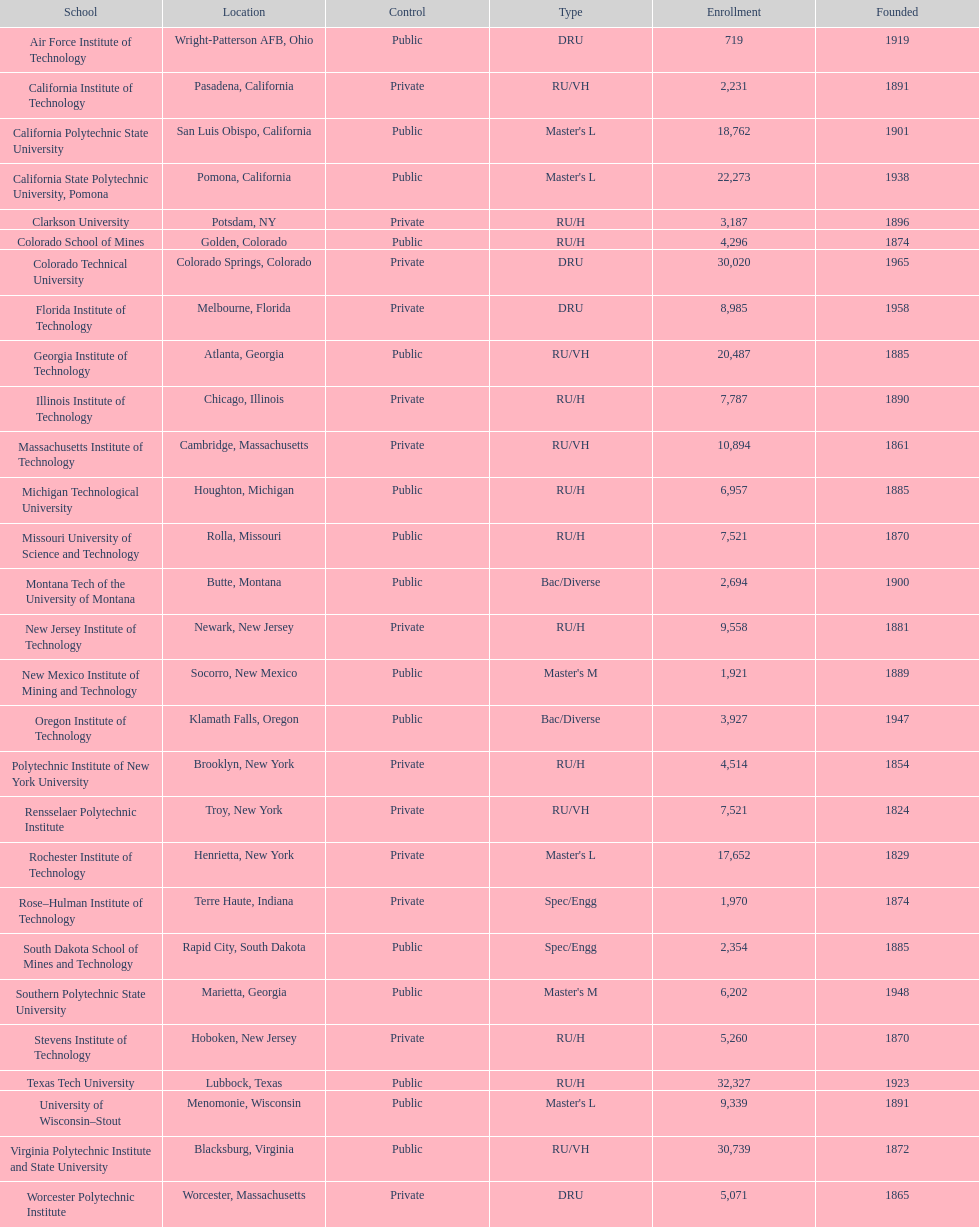Which us technological university has the top enrollment numbers? Texas Tech University. 